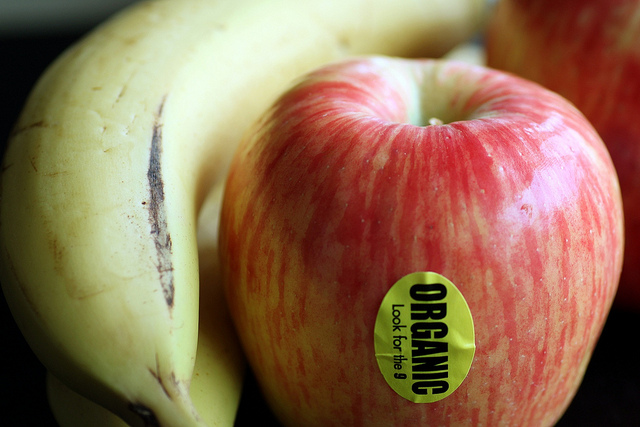Identify the text contained in this image. ORGANIC Look for the 6 